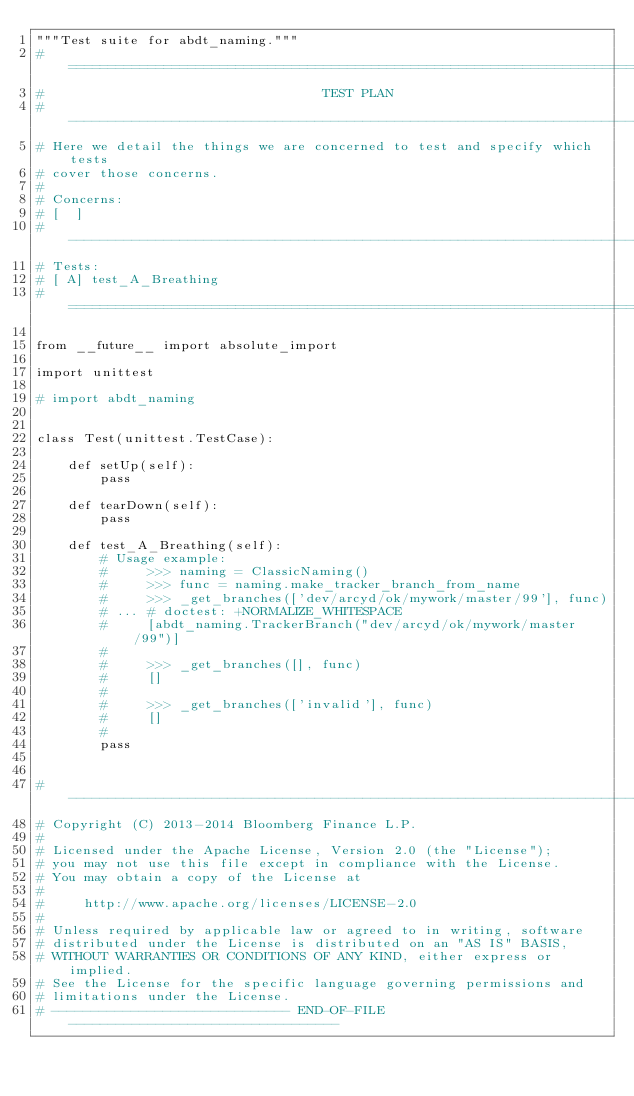<code> <loc_0><loc_0><loc_500><loc_500><_Python_>"""Test suite for abdt_naming."""
# =============================================================================
#                                   TEST PLAN
# -----------------------------------------------------------------------------
# Here we detail the things we are concerned to test and specify which tests
# cover those concerns.
#
# Concerns:
# [  ]
# -----------------------------------------------------------------------------
# Tests:
# [ A] test_A_Breathing
# =============================================================================

from __future__ import absolute_import

import unittest

# import abdt_naming


class Test(unittest.TestCase):

    def setUp(self):
        pass

    def tearDown(self):
        pass

    def test_A_Breathing(self):
        # Usage example:
        #     >>> naming = ClassicNaming()
        #     >>> func = naming.make_tracker_branch_from_name
        #     >>> _get_branches(['dev/arcyd/ok/mywork/master/99'], func)
        # ... # doctest: +NORMALIZE_WHITESPACE
        #     [abdt_naming.TrackerBranch("dev/arcyd/ok/mywork/master/99")]
        #
        #     >>> _get_branches([], func)
        #     []
        #
        #     >>> _get_branches(['invalid'], func)
        #     []
        #
        pass


# -----------------------------------------------------------------------------
# Copyright (C) 2013-2014 Bloomberg Finance L.P.
#
# Licensed under the Apache License, Version 2.0 (the "License");
# you may not use this file except in compliance with the License.
# You may obtain a copy of the License at
#
#     http://www.apache.org/licenses/LICENSE-2.0
#
# Unless required by applicable law or agreed to in writing, software
# distributed under the License is distributed on an "AS IS" BASIS,
# WITHOUT WARRANTIES OR CONDITIONS OF ANY KIND, either express or implied.
# See the License for the specific language governing permissions and
# limitations under the License.
# ------------------------------ END-OF-FILE ----------------------------------
</code> 